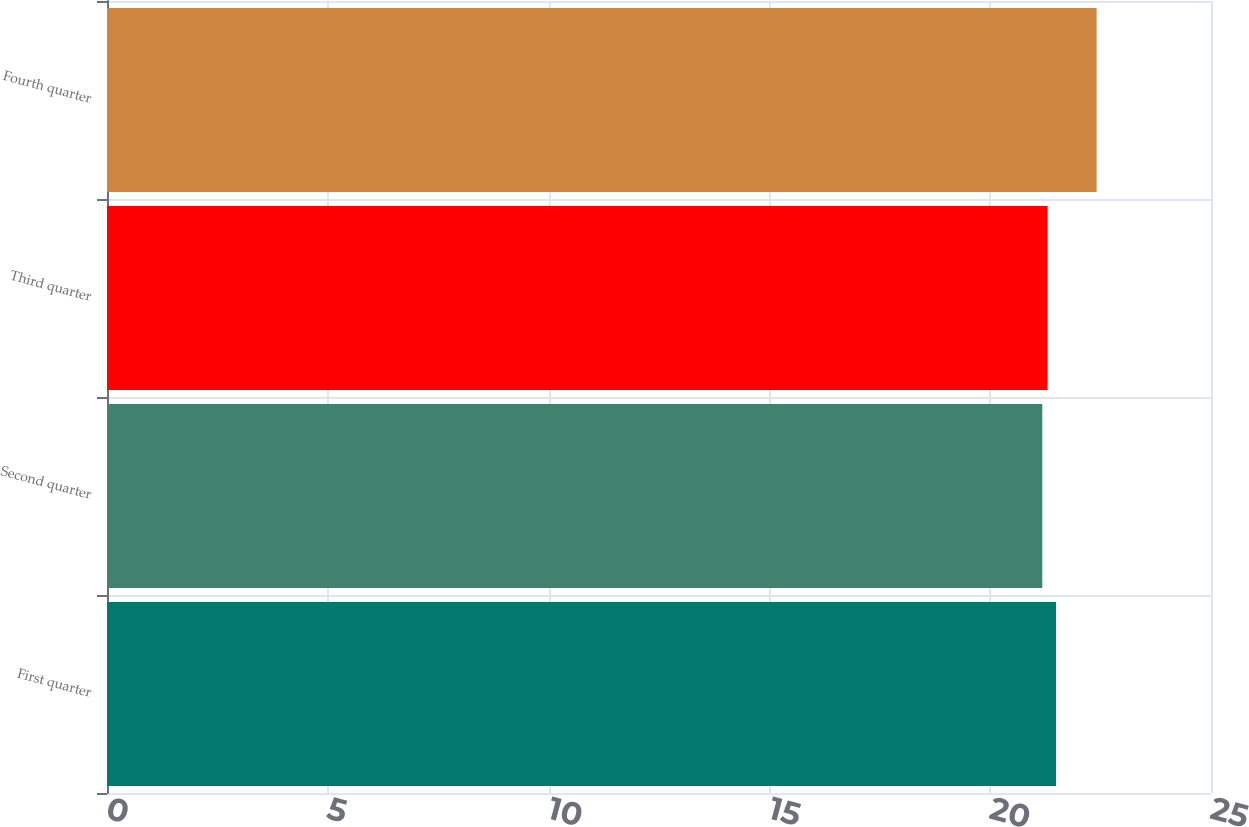<chart> <loc_0><loc_0><loc_500><loc_500><bar_chart><fcel>First quarter<fcel>Second quarter<fcel>Third quarter<fcel>Fourth quarter<nl><fcel>21.49<fcel>21.18<fcel>21.3<fcel>22.41<nl></chart> 